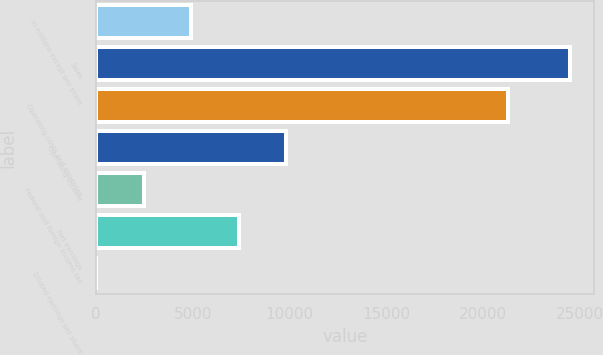Convert chart to OTSL. <chart><loc_0><loc_0><loc_500><loc_500><bar_chart><fcel>in millions except per share<fcel>Sales<fcel>Operating costs and expenses<fcel>Operating income<fcel>Federal and foreign income tax<fcel>Net earnings<fcel>Diluted earnings per share<nl><fcel>4911.35<fcel>24508<fcel>21315<fcel>9810.51<fcel>2461.77<fcel>7360.93<fcel>12.19<nl></chart> 